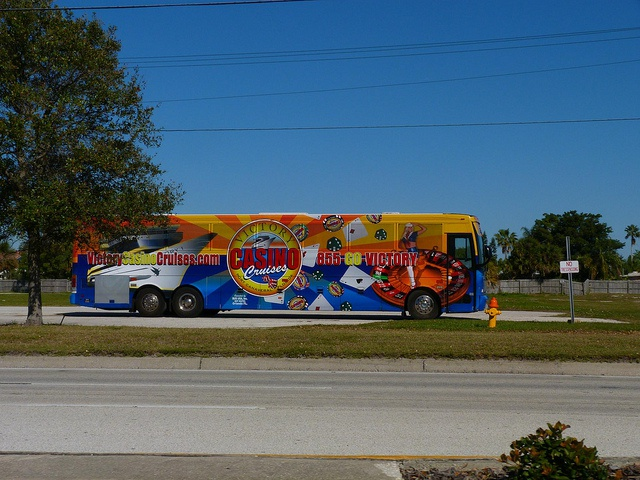Describe the objects in this image and their specific colors. I can see bus in black, navy, maroon, and olive tones and fire hydrant in black, orange, olive, maroon, and red tones in this image. 